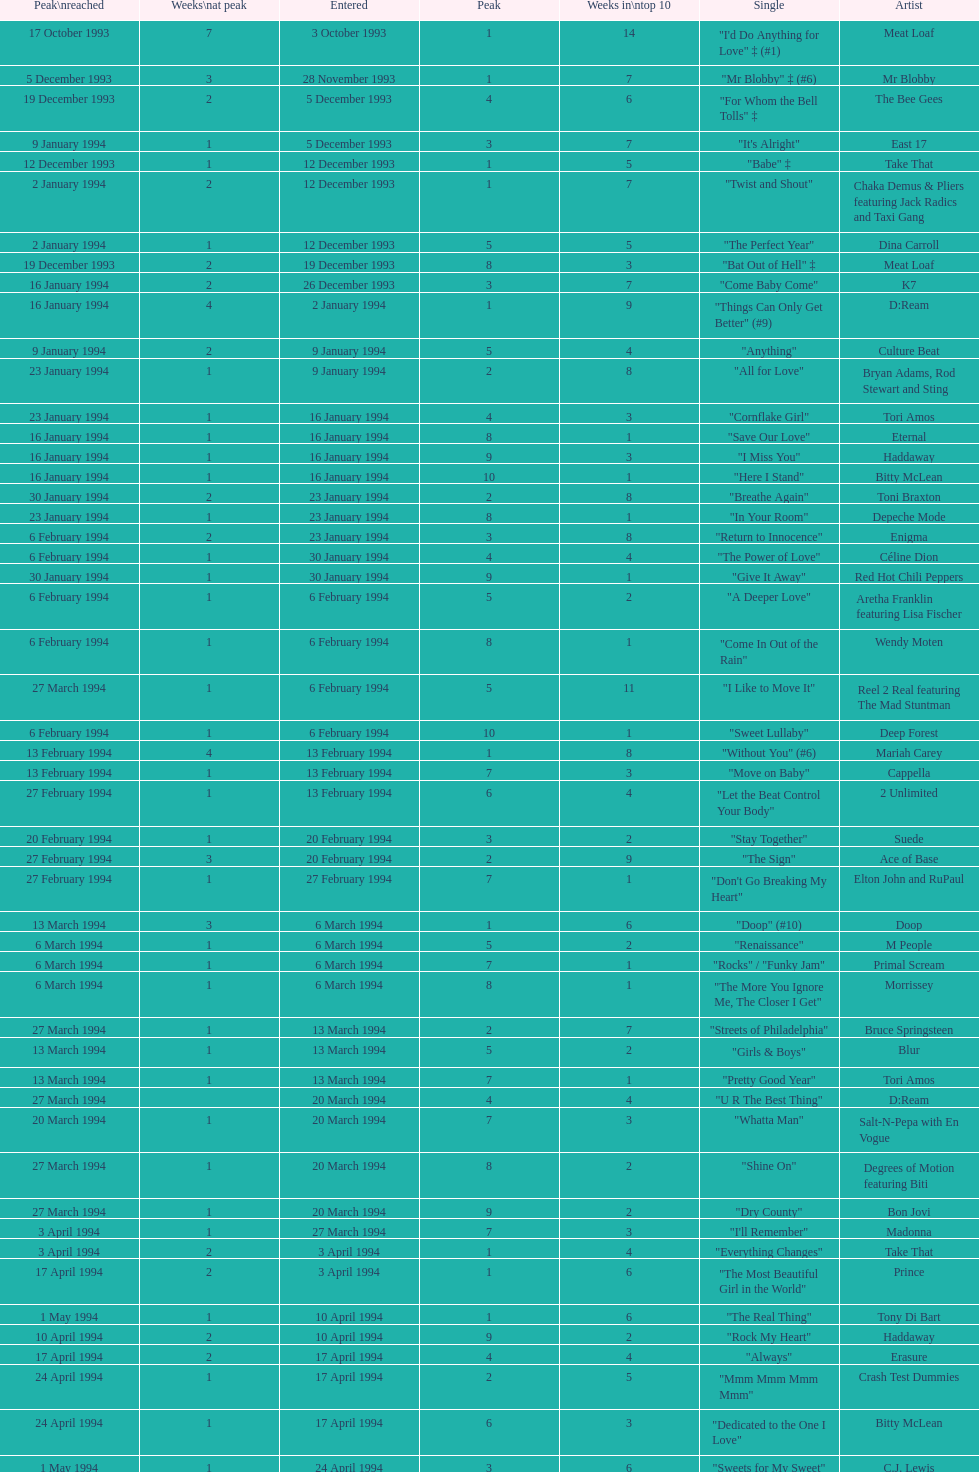This song released by celine dion spent 17 weeks on the uk singles chart in 1994, which one was it? "Think Twice". 